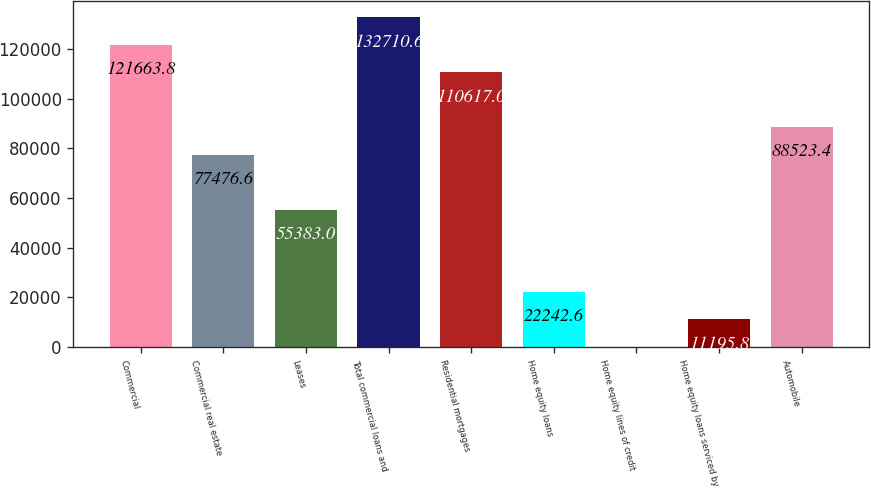Convert chart to OTSL. <chart><loc_0><loc_0><loc_500><loc_500><bar_chart><fcel>Commercial<fcel>Commercial real estate<fcel>Leases<fcel>Total commercial loans and<fcel>Residential mortgages<fcel>Home equity loans<fcel>Home equity lines of credit<fcel>Home equity loans serviced by<fcel>Automobile<nl><fcel>121664<fcel>77476.6<fcel>55383<fcel>132711<fcel>110617<fcel>22242.6<fcel>149<fcel>11195.8<fcel>88523.4<nl></chart> 